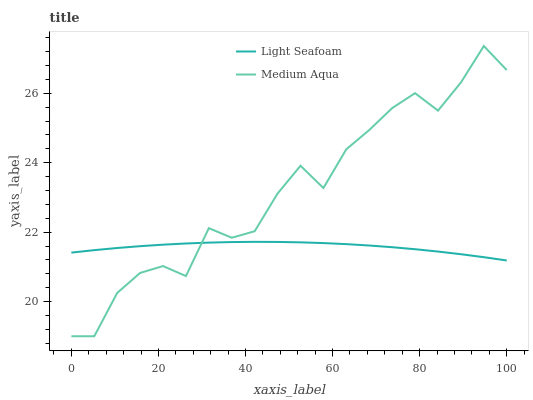Does Light Seafoam have the minimum area under the curve?
Answer yes or no. Yes. Does Medium Aqua have the maximum area under the curve?
Answer yes or no. Yes. Does Medium Aqua have the minimum area under the curve?
Answer yes or no. No. Is Light Seafoam the smoothest?
Answer yes or no. Yes. Is Medium Aqua the roughest?
Answer yes or no. Yes. Is Medium Aqua the smoothest?
Answer yes or no. No. Does Medium Aqua have the lowest value?
Answer yes or no. Yes. Does Medium Aqua have the highest value?
Answer yes or no. Yes. Does Medium Aqua intersect Light Seafoam?
Answer yes or no. Yes. Is Medium Aqua less than Light Seafoam?
Answer yes or no. No. Is Medium Aqua greater than Light Seafoam?
Answer yes or no. No. 